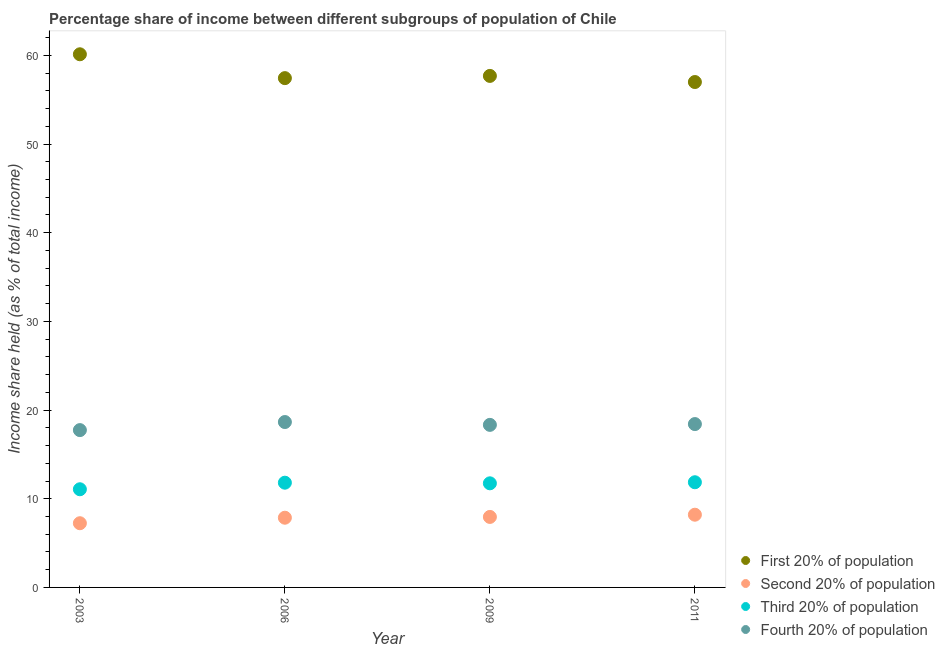How many different coloured dotlines are there?
Provide a succinct answer. 4. Is the number of dotlines equal to the number of legend labels?
Offer a terse response. Yes. What is the share of the income held by fourth 20% of the population in 2006?
Your answer should be very brief. 18.65. Across all years, what is the maximum share of the income held by fourth 20% of the population?
Offer a terse response. 18.65. Across all years, what is the minimum share of the income held by fourth 20% of the population?
Your answer should be compact. 17.74. What is the total share of the income held by fourth 20% of the population in the graph?
Ensure brevity in your answer.  73.14. What is the difference between the share of the income held by fourth 20% of the population in 2006 and that in 2009?
Give a very brief answer. 0.32. What is the difference between the share of the income held by third 20% of the population in 2006 and the share of the income held by fourth 20% of the population in 2009?
Offer a terse response. -6.52. What is the average share of the income held by third 20% of the population per year?
Give a very brief answer. 11.62. In the year 2003, what is the difference between the share of the income held by fourth 20% of the population and share of the income held by second 20% of the population?
Ensure brevity in your answer.  10.5. In how many years, is the share of the income held by second 20% of the population greater than 6 %?
Your answer should be very brief. 4. What is the ratio of the share of the income held by second 20% of the population in 2003 to that in 2006?
Provide a succinct answer. 0.92. Is the share of the income held by second 20% of the population in 2003 less than that in 2006?
Your answer should be very brief. Yes. Is the difference between the share of the income held by second 20% of the population in 2003 and 2011 greater than the difference between the share of the income held by first 20% of the population in 2003 and 2011?
Provide a succinct answer. No. What is the difference between the highest and the second highest share of the income held by first 20% of the population?
Give a very brief answer. 2.44. What is the difference between the highest and the lowest share of the income held by fourth 20% of the population?
Your answer should be compact. 0.91. Is it the case that in every year, the sum of the share of the income held by first 20% of the population and share of the income held by second 20% of the population is greater than the share of the income held by third 20% of the population?
Ensure brevity in your answer.  Yes. Does the share of the income held by third 20% of the population monotonically increase over the years?
Offer a terse response. No. How many years are there in the graph?
Keep it short and to the point. 4. What is the difference between two consecutive major ticks on the Y-axis?
Make the answer very short. 10. Does the graph contain any zero values?
Offer a very short reply. No. Where does the legend appear in the graph?
Give a very brief answer. Bottom right. How many legend labels are there?
Keep it short and to the point. 4. How are the legend labels stacked?
Your answer should be very brief. Vertical. What is the title of the graph?
Offer a terse response. Percentage share of income between different subgroups of population of Chile. Does "Australia" appear as one of the legend labels in the graph?
Your answer should be compact. No. What is the label or title of the X-axis?
Offer a very short reply. Year. What is the label or title of the Y-axis?
Your response must be concise. Income share held (as % of total income). What is the Income share held (as % of total income) of First 20% of population in 2003?
Provide a short and direct response. 60.12. What is the Income share held (as % of total income) of Second 20% of population in 2003?
Provide a short and direct response. 7.24. What is the Income share held (as % of total income) of Third 20% of population in 2003?
Offer a terse response. 11.07. What is the Income share held (as % of total income) in Fourth 20% of population in 2003?
Your answer should be compact. 17.74. What is the Income share held (as % of total income) of First 20% of population in 2006?
Provide a succinct answer. 57.43. What is the Income share held (as % of total income) of Second 20% of population in 2006?
Offer a terse response. 7.86. What is the Income share held (as % of total income) in Third 20% of population in 2006?
Your response must be concise. 11.81. What is the Income share held (as % of total income) of Fourth 20% of population in 2006?
Your response must be concise. 18.65. What is the Income share held (as % of total income) in First 20% of population in 2009?
Your answer should be compact. 57.68. What is the Income share held (as % of total income) of Second 20% of population in 2009?
Offer a very short reply. 7.95. What is the Income share held (as % of total income) of Third 20% of population in 2009?
Your response must be concise. 11.74. What is the Income share held (as % of total income) of Fourth 20% of population in 2009?
Offer a very short reply. 18.33. What is the Income share held (as % of total income) of First 20% of population in 2011?
Give a very brief answer. 56.99. What is the Income share held (as % of total income) in Second 20% of population in 2011?
Offer a terse response. 8.2. What is the Income share held (as % of total income) in Third 20% of population in 2011?
Offer a terse response. 11.86. What is the Income share held (as % of total income) in Fourth 20% of population in 2011?
Offer a terse response. 18.42. Across all years, what is the maximum Income share held (as % of total income) of First 20% of population?
Your answer should be compact. 60.12. Across all years, what is the maximum Income share held (as % of total income) of Third 20% of population?
Provide a succinct answer. 11.86. Across all years, what is the maximum Income share held (as % of total income) of Fourth 20% of population?
Offer a very short reply. 18.65. Across all years, what is the minimum Income share held (as % of total income) of First 20% of population?
Give a very brief answer. 56.99. Across all years, what is the minimum Income share held (as % of total income) in Second 20% of population?
Keep it short and to the point. 7.24. Across all years, what is the minimum Income share held (as % of total income) in Third 20% of population?
Provide a short and direct response. 11.07. Across all years, what is the minimum Income share held (as % of total income) of Fourth 20% of population?
Offer a terse response. 17.74. What is the total Income share held (as % of total income) in First 20% of population in the graph?
Provide a succinct answer. 232.22. What is the total Income share held (as % of total income) in Second 20% of population in the graph?
Give a very brief answer. 31.25. What is the total Income share held (as % of total income) of Third 20% of population in the graph?
Your answer should be very brief. 46.48. What is the total Income share held (as % of total income) in Fourth 20% of population in the graph?
Make the answer very short. 73.14. What is the difference between the Income share held (as % of total income) of First 20% of population in 2003 and that in 2006?
Your response must be concise. 2.69. What is the difference between the Income share held (as % of total income) of Second 20% of population in 2003 and that in 2006?
Provide a succinct answer. -0.62. What is the difference between the Income share held (as % of total income) in Third 20% of population in 2003 and that in 2006?
Ensure brevity in your answer.  -0.74. What is the difference between the Income share held (as % of total income) of Fourth 20% of population in 2003 and that in 2006?
Ensure brevity in your answer.  -0.91. What is the difference between the Income share held (as % of total income) in First 20% of population in 2003 and that in 2009?
Your response must be concise. 2.44. What is the difference between the Income share held (as % of total income) of Second 20% of population in 2003 and that in 2009?
Keep it short and to the point. -0.71. What is the difference between the Income share held (as % of total income) of Third 20% of population in 2003 and that in 2009?
Your answer should be very brief. -0.67. What is the difference between the Income share held (as % of total income) of Fourth 20% of population in 2003 and that in 2009?
Provide a short and direct response. -0.59. What is the difference between the Income share held (as % of total income) of First 20% of population in 2003 and that in 2011?
Keep it short and to the point. 3.13. What is the difference between the Income share held (as % of total income) of Second 20% of population in 2003 and that in 2011?
Offer a very short reply. -0.96. What is the difference between the Income share held (as % of total income) in Third 20% of population in 2003 and that in 2011?
Ensure brevity in your answer.  -0.79. What is the difference between the Income share held (as % of total income) in Fourth 20% of population in 2003 and that in 2011?
Your answer should be compact. -0.68. What is the difference between the Income share held (as % of total income) in Second 20% of population in 2006 and that in 2009?
Keep it short and to the point. -0.09. What is the difference between the Income share held (as % of total income) in Third 20% of population in 2006 and that in 2009?
Your response must be concise. 0.07. What is the difference between the Income share held (as % of total income) in Fourth 20% of population in 2006 and that in 2009?
Ensure brevity in your answer.  0.32. What is the difference between the Income share held (as % of total income) of First 20% of population in 2006 and that in 2011?
Offer a very short reply. 0.44. What is the difference between the Income share held (as % of total income) in Second 20% of population in 2006 and that in 2011?
Offer a terse response. -0.34. What is the difference between the Income share held (as % of total income) of Fourth 20% of population in 2006 and that in 2011?
Make the answer very short. 0.23. What is the difference between the Income share held (as % of total income) in First 20% of population in 2009 and that in 2011?
Offer a very short reply. 0.69. What is the difference between the Income share held (as % of total income) in Third 20% of population in 2009 and that in 2011?
Your answer should be very brief. -0.12. What is the difference between the Income share held (as % of total income) of Fourth 20% of population in 2009 and that in 2011?
Give a very brief answer. -0.09. What is the difference between the Income share held (as % of total income) of First 20% of population in 2003 and the Income share held (as % of total income) of Second 20% of population in 2006?
Your answer should be compact. 52.26. What is the difference between the Income share held (as % of total income) of First 20% of population in 2003 and the Income share held (as % of total income) of Third 20% of population in 2006?
Offer a very short reply. 48.31. What is the difference between the Income share held (as % of total income) of First 20% of population in 2003 and the Income share held (as % of total income) of Fourth 20% of population in 2006?
Provide a succinct answer. 41.47. What is the difference between the Income share held (as % of total income) in Second 20% of population in 2003 and the Income share held (as % of total income) in Third 20% of population in 2006?
Offer a very short reply. -4.57. What is the difference between the Income share held (as % of total income) of Second 20% of population in 2003 and the Income share held (as % of total income) of Fourth 20% of population in 2006?
Keep it short and to the point. -11.41. What is the difference between the Income share held (as % of total income) of Third 20% of population in 2003 and the Income share held (as % of total income) of Fourth 20% of population in 2006?
Keep it short and to the point. -7.58. What is the difference between the Income share held (as % of total income) in First 20% of population in 2003 and the Income share held (as % of total income) in Second 20% of population in 2009?
Give a very brief answer. 52.17. What is the difference between the Income share held (as % of total income) in First 20% of population in 2003 and the Income share held (as % of total income) in Third 20% of population in 2009?
Your answer should be very brief. 48.38. What is the difference between the Income share held (as % of total income) in First 20% of population in 2003 and the Income share held (as % of total income) in Fourth 20% of population in 2009?
Your response must be concise. 41.79. What is the difference between the Income share held (as % of total income) of Second 20% of population in 2003 and the Income share held (as % of total income) of Fourth 20% of population in 2009?
Your response must be concise. -11.09. What is the difference between the Income share held (as % of total income) in Third 20% of population in 2003 and the Income share held (as % of total income) in Fourth 20% of population in 2009?
Provide a short and direct response. -7.26. What is the difference between the Income share held (as % of total income) of First 20% of population in 2003 and the Income share held (as % of total income) of Second 20% of population in 2011?
Offer a very short reply. 51.92. What is the difference between the Income share held (as % of total income) of First 20% of population in 2003 and the Income share held (as % of total income) of Third 20% of population in 2011?
Ensure brevity in your answer.  48.26. What is the difference between the Income share held (as % of total income) of First 20% of population in 2003 and the Income share held (as % of total income) of Fourth 20% of population in 2011?
Keep it short and to the point. 41.7. What is the difference between the Income share held (as % of total income) in Second 20% of population in 2003 and the Income share held (as % of total income) in Third 20% of population in 2011?
Provide a succinct answer. -4.62. What is the difference between the Income share held (as % of total income) in Second 20% of population in 2003 and the Income share held (as % of total income) in Fourth 20% of population in 2011?
Your answer should be very brief. -11.18. What is the difference between the Income share held (as % of total income) of Third 20% of population in 2003 and the Income share held (as % of total income) of Fourth 20% of population in 2011?
Your answer should be very brief. -7.35. What is the difference between the Income share held (as % of total income) in First 20% of population in 2006 and the Income share held (as % of total income) in Second 20% of population in 2009?
Ensure brevity in your answer.  49.48. What is the difference between the Income share held (as % of total income) in First 20% of population in 2006 and the Income share held (as % of total income) in Third 20% of population in 2009?
Offer a very short reply. 45.69. What is the difference between the Income share held (as % of total income) of First 20% of population in 2006 and the Income share held (as % of total income) of Fourth 20% of population in 2009?
Your answer should be very brief. 39.1. What is the difference between the Income share held (as % of total income) in Second 20% of population in 2006 and the Income share held (as % of total income) in Third 20% of population in 2009?
Your response must be concise. -3.88. What is the difference between the Income share held (as % of total income) in Second 20% of population in 2006 and the Income share held (as % of total income) in Fourth 20% of population in 2009?
Offer a terse response. -10.47. What is the difference between the Income share held (as % of total income) of Third 20% of population in 2006 and the Income share held (as % of total income) of Fourth 20% of population in 2009?
Keep it short and to the point. -6.52. What is the difference between the Income share held (as % of total income) of First 20% of population in 2006 and the Income share held (as % of total income) of Second 20% of population in 2011?
Ensure brevity in your answer.  49.23. What is the difference between the Income share held (as % of total income) of First 20% of population in 2006 and the Income share held (as % of total income) of Third 20% of population in 2011?
Your response must be concise. 45.57. What is the difference between the Income share held (as % of total income) in First 20% of population in 2006 and the Income share held (as % of total income) in Fourth 20% of population in 2011?
Provide a succinct answer. 39.01. What is the difference between the Income share held (as % of total income) of Second 20% of population in 2006 and the Income share held (as % of total income) of Third 20% of population in 2011?
Make the answer very short. -4. What is the difference between the Income share held (as % of total income) in Second 20% of population in 2006 and the Income share held (as % of total income) in Fourth 20% of population in 2011?
Your answer should be very brief. -10.56. What is the difference between the Income share held (as % of total income) of Third 20% of population in 2006 and the Income share held (as % of total income) of Fourth 20% of population in 2011?
Give a very brief answer. -6.61. What is the difference between the Income share held (as % of total income) of First 20% of population in 2009 and the Income share held (as % of total income) of Second 20% of population in 2011?
Ensure brevity in your answer.  49.48. What is the difference between the Income share held (as % of total income) of First 20% of population in 2009 and the Income share held (as % of total income) of Third 20% of population in 2011?
Offer a terse response. 45.82. What is the difference between the Income share held (as % of total income) of First 20% of population in 2009 and the Income share held (as % of total income) of Fourth 20% of population in 2011?
Give a very brief answer. 39.26. What is the difference between the Income share held (as % of total income) in Second 20% of population in 2009 and the Income share held (as % of total income) in Third 20% of population in 2011?
Provide a short and direct response. -3.91. What is the difference between the Income share held (as % of total income) of Second 20% of population in 2009 and the Income share held (as % of total income) of Fourth 20% of population in 2011?
Give a very brief answer. -10.47. What is the difference between the Income share held (as % of total income) of Third 20% of population in 2009 and the Income share held (as % of total income) of Fourth 20% of population in 2011?
Offer a terse response. -6.68. What is the average Income share held (as % of total income) in First 20% of population per year?
Give a very brief answer. 58.05. What is the average Income share held (as % of total income) in Second 20% of population per year?
Offer a terse response. 7.81. What is the average Income share held (as % of total income) of Third 20% of population per year?
Provide a short and direct response. 11.62. What is the average Income share held (as % of total income) in Fourth 20% of population per year?
Keep it short and to the point. 18.29. In the year 2003, what is the difference between the Income share held (as % of total income) of First 20% of population and Income share held (as % of total income) of Second 20% of population?
Offer a terse response. 52.88. In the year 2003, what is the difference between the Income share held (as % of total income) of First 20% of population and Income share held (as % of total income) of Third 20% of population?
Offer a very short reply. 49.05. In the year 2003, what is the difference between the Income share held (as % of total income) in First 20% of population and Income share held (as % of total income) in Fourth 20% of population?
Your answer should be compact. 42.38. In the year 2003, what is the difference between the Income share held (as % of total income) of Second 20% of population and Income share held (as % of total income) of Third 20% of population?
Your response must be concise. -3.83. In the year 2003, what is the difference between the Income share held (as % of total income) of Third 20% of population and Income share held (as % of total income) of Fourth 20% of population?
Offer a very short reply. -6.67. In the year 2006, what is the difference between the Income share held (as % of total income) in First 20% of population and Income share held (as % of total income) in Second 20% of population?
Your answer should be very brief. 49.57. In the year 2006, what is the difference between the Income share held (as % of total income) in First 20% of population and Income share held (as % of total income) in Third 20% of population?
Keep it short and to the point. 45.62. In the year 2006, what is the difference between the Income share held (as % of total income) in First 20% of population and Income share held (as % of total income) in Fourth 20% of population?
Your response must be concise. 38.78. In the year 2006, what is the difference between the Income share held (as % of total income) in Second 20% of population and Income share held (as % of total income) in Third 20% of population?
Your answer should be compact. -3.95. In the year 2006, what is the difference between the Income share held (as % of total income) of Second 20% of population and Income share held (as % of total income) of Fourth 20% of population?
Provide a succinct answer. -10.79. In the year 2006, what is the difference between the Income share held (as % of total income) in Third 20% of population and Income share held (as % of total income) in Fourth 20% of population?
Give a very brief answer. -6.84. In the year 2009, what is the difference between the Income share held (as % of total income) of First 20% of population and Income share held (as % of total income) of Second 20% of population?
Your answer should be very brief. 49.73. In the year 2009, what is the difference between the Income share held (as % of total income) of First 20% of population and Income share held (as % of total income) of Third 20% of population?
Keep it short and to the point. 45.94. In the year 2009, what is the difference between the Income share held (as % of total income) of First 20% of population and Income share held (as % of total income) of Fourth 20% of population?
Your answer should be very brief. 39.35. In the year 2009, what is the difference between the Income share held (as % of total income) of Second 20% of population and Income share held (as % of total income) of Third 20% of population?
Ensure brevity in your answer.  -3.79. In the year 2009, what is the difference between the Income share held (as % of total income) of Second 20% of population and Income share held (as % of total income) of Fourth 20% of population?
Offer a terse response. -10.38. In the year 2009, what is the difference between the Income share held (as % of total income) in Third 20% of population and Income share held (as % of total income) in Fourth 20% of population?
Make the answer very short. -6.59. In the year 2011, what is the difference between the Income share held (as % of total income) of First 20% of population and Income share held (as % of total income) of Second 20% of population?
Your answer should be very brief. 48.79. In the year 2011, what is the difference between the Income share held (as % of total income) in First 20% of population and Income share held (as % of total income) in Third 20% of population?
Offer a terse response. 45.13. In the year 2011, what is the difference between the Income share held (as % of total income) in First 20% of population and Income share held (as % of total income) in Fourth 20% of population?
Provide a short and direct response. 38.57. In the year 2011, what is the difference between the Income share held (as % of total income) in Second 20% of population and Income share held (as % of total income) in Third 20% of population?
Ensure brevity in your answer.  -3.66. In the year 2011, what is the difference between the Income share held (as % of total income) of Second 20% of population and Income share held (as % of total income) of Fourth 20% of population?
Ensure brevity in your answer.  -10.22. In the year 2011, what is the difference between the Income share held (as % of total income) of Third 20% of population and Income share held (as % of total income) of Fourth 20% of population?
Ensure brevity in your answer.  -6.56. What is the ratio of the Income share held (as % of total income) in First 20% of population in 2003 to that in 2006?
Offer a terse response. 1.05. What is the ratio of the Income share held (as % of total income) in Second 20% of population in 2003 to that in 2006?
Ensure brevity in your answer.  0.92. What is the ratio of the Income share held (as % of total income) of Third 20% of population in 2003 to that in 2006?
Keep it short and to the point. 0.94. What is the ratio of the Income share held (as % of total income) of Fourth 20% of population in 2003 to that in 2006?
Keep it short and to the point. 0.95. What is the ratio of the Income share held (as % of total income) in First 20% of population in 2003 to that in 2009?
Give a very brief answer. 1.04. What is the ratio of the Income share held (as % of total income) of Second 20% of population in 2003 to that in 2009?
Ensure brevity in your answer.  0.91. What is the ratio of the Income share held (as % of total income) of Third 20% of population in 2003 to that in 2009?
Ensure brevity in your answer.  0.94. What is the ratio of the Income share held (as % of total income) in Fourth 20% of population in 2003 to that in 2009?
Provide a succinct answer. 0.97. What is the ratio of the Income share held (as % of total income) in First 20% of population in 2003 to that in 2011?
Offer a terse response. 1.05. What is the ratio of the Income share held (as % of total income) in Second 20% of population in 2003 to that in 2011?
Offer a very short reply. 0.88. What is the ratio of the Income share held (as % of total income) of Third 20% of population in 2003 to that in 2011?
Keep it short and to the point. 0.93. What is the ratio of the Income share held (as % of total income) in Fourth 20% of population in 2003 to that in 2011?
Your answer should be very brief. 0.96. What is the ratio of the Income share held (as % of total income) of Second 20% of population in 2006 to that in 2009?
Your answer should be very brief. 0.99. What is the ratio of the Income share held (as % of total income) of Third 20% of population in 2006 to that in 2009?
Your answer should be compact. 1.01. What is the ratio of the Income share held (as % of total income) of Fourth 20% of population in 2006 to that in 2009?
Offer a very short reply. 1.02. What is the ratio of the Income share held (as % of total income) of First 20% of population in 2006 to that in 2011?
Offer a terse response. 1.01. What is the ratio of the Income share held (as % of total income) of Second 20% of population in 2006 to that in 2011?
Offer a terse response. 0.96. What is the ratio of the Income share held (as % of total income) in Fourth 20% of population in 2006 to that in 2011?
Ensure brevity in your answer.  1.01. What is the ratio of the Income share held (as % of total income) in First 20% of population in 2009 to that in 2011?
Provide a succinct answer. 1.01. What is the ratio of the Income share held (as % of total income) of Second 20% of population in 2009 to that in 2011?
Offer a terse response. 0.97. What is the difference between the highest and the second highest Income share held (as % of total income) in First 20% of population?
Keep it short and to the point. 2.44. What is the difference between the highest and the second highest Income share held (as % of total income) in Second 20% of population?
Keep it short and to the point. 0.25. What is the difference between the highest and the second highest Income share held (as % of total income) of Third 20% of population?
Offer a terse response. 0.05. What is the difference between the highest and the second highest Income share held (as % of total income) in Fourth 20% of population?
Ensure brevity in your answer.  0.23. What is the difference between the highest and the lowest Income share held (as % of total income) in First 20% of population?
Keep it short and to the point. 3.13. What is the difference between the highest and the lowest Income share held (as % of total income) in Second 20% of population?
Your response must be concise. 0.96. What is the difference between the highest and the lowest Income share held (as % of total income) of Third 20% of population?
Provide a short and direct response. 0.79. What is the difference between the highest and the lowest Income share held (as % of total income) of Fourth 20% of population?
Provide a succinct answer. 0.91. 